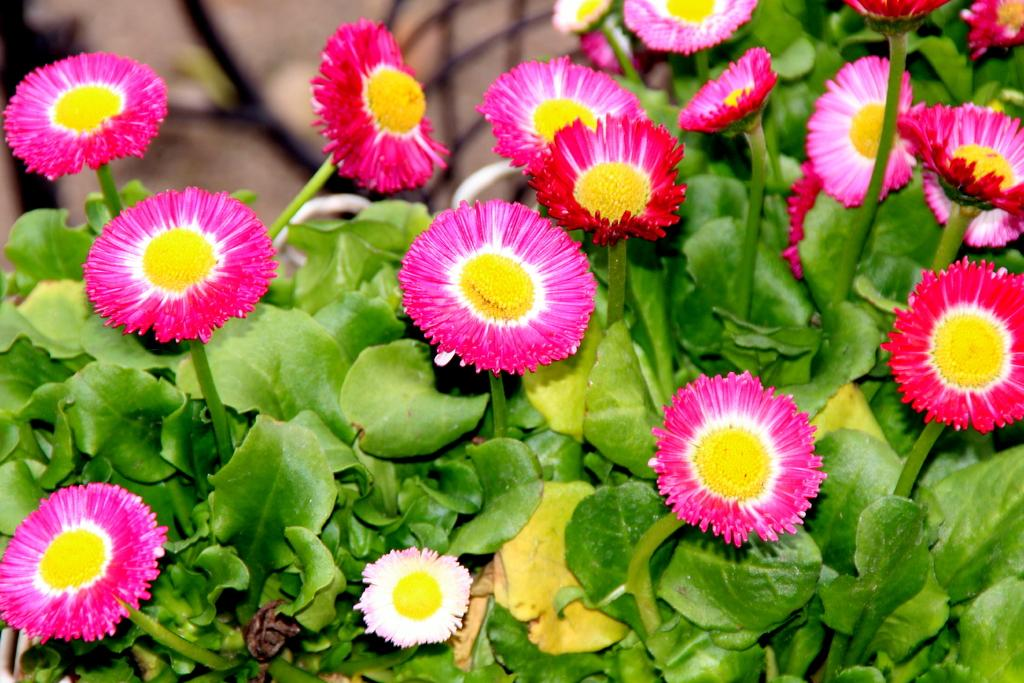What type of plants can be seen in the image? There are flowers and leaves in the image. Can you describe the appearance of the flowers? Unfortunately, the specific appearance of the flowers cannot be determined from the provided facts. Are there any other elements present in the image besides the flowers and leaves? No additional elements are mentioned in the provided facts. What type of veil is draped over the flowers in the image? There is no veil present in the image; it only features flowers and leaves. How many seats are visible in the image? There are no seats present in the image; it only features flowers and leaves. 